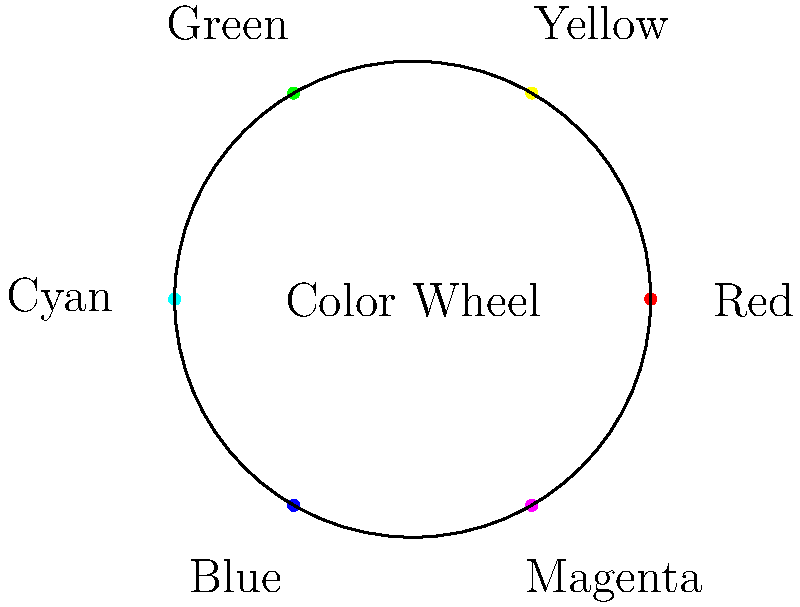In superhero costume design, which color combination would create the strongest visual contrast according to color theory principles? To answer this question, we need to understand the basics of color theory and how it applies to superhero costume design:

1. The color wheel shown in the image represents the primary and secondary colors arranged in their spectral order.

2. In color theory, colors that are opposite each other on the color wheel are called complementary colors. These create the strongest contrast when used together.

3. Looking at the color wheel, we can identify three pairs of complementary colors:
   - Red and Cyan
   - Yellow and Blue
   - Green and Magenta

4. Among these, the pair that typically creates the strongest visual contrast is red and cyan (blue-green).

5. In superhero costume design, high contrast color combinations are often used to make the character stand out and create a memorable visual impact.

6. For example, Superman's costume uses a combination of red and blue, which are near-complementary colors, creating a strong visual contrast.

7. However, if we strictly follow color theory principles for maximum contrast, a red and cyan combination would be even more striking.

Therefore, based on color theory principles, the combination of red and cyan would create the strongest visual contrast in superhero costume design.
Answer: Red and Cyan 